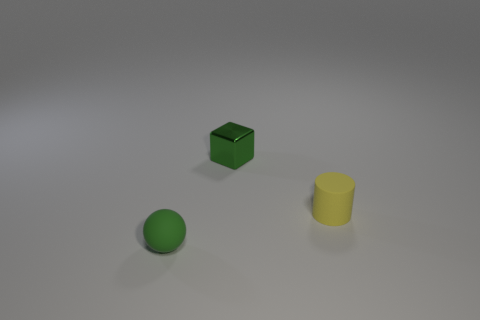Add 2 blocks. How many objects exist? 5 Subtract all blocks. How many objects are left? 2 Add 1 cubes. How many cubes exist? 2 Subtract 1 yellow cylinders. How many objects are left? 2 Subtract all metallic blocks. Subtract all small rubber cylinders. How many objects are left? 1 Add 2 tiny objects. How many tiny objects are left? 5 